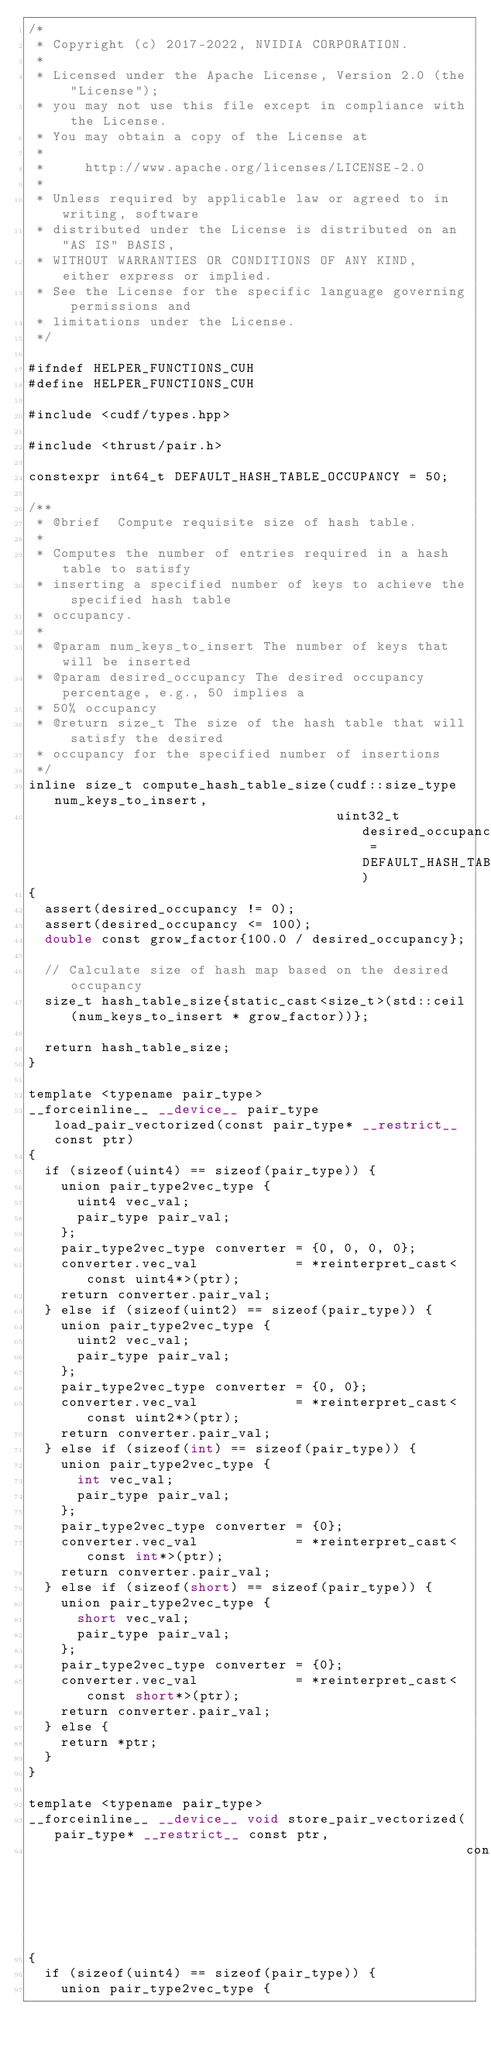<code> <loc_0><loc_0><loc_500><loc_500><_Cuda_>/*
 * Copyright (c) 2017-2022, NVIDIA CORPORATION.
 *
 * Licensed under the Apache License, Version 2.0 (the "License");
 * you may not use this file except in compliance with the License.
 * You may obtain a copy of the License at
 *
 *     http://www.apache.org/licenses/LICENSE-2.0
 *
 * Unless required by applicable law or agreed to in writing, software
 * distributed under the License is distributed on an "AS IS" BASIS,
 * WITHOUT WARRANTIES OR CONDITIONS OF ANY KIND, either express or implied.
 * See the License for the specific language governing permissions and
 * limitations under the License.
 */

#ifndef HELPER_FUNCTIONS_CUH
#define HELPER_FUNCTIONS_CUH

#include <cudf/types.hpp>

#include <thrust/pair.h>

constexpr int64_t DEFAULT_HASH_TABLE_OCCUPANCY = 50;

/**
 * @brief  Compute requisite size of hash table.
 *
 * Computes the number of entries required in a hash table to satisfy
 * inserting a specified number of keys to achieve the specified hash table
 * occupancy.
 *
 * @param num_keys_to_insert The number of keys that will be inserted
 * @param desired_occupancy The desired occupancy percentage, e.g., 50 implies a
 * 50% occupancy
 * @return size_t The size of the hash table that will satisfy the desired
 * occupancy for the specified number of insertions
 */
inline size_t compute_hash_table_size(cudf::size_type num_keys_to_insert,
                                      uint32_t desired_occupancy = DEFAULT_HASH_TABLE_OCCUPANCY)
{
  assert(desired_occupancy != 0);
  assert(desired_occupancy <= 100);
  double const grow_factor{100.0 / desired_occupancy};

  // Calculate size of hash map based on the desired occupancy
  size_t hash_table_size{static_cast<size_t>(std::ceil(num_keys_to_insert * grow_factor))};

  return hash_table_size;
}

template <typename pair_type>
__forceinline__ __device__ pair_type load_pair_vectorized(const pair_type* __restrict__ const ptr)
{
  if (sizeof(uint4) == sizeof(pair_type)) {
    union pair_type2vec_type {
      uint4 vec_val;
      pair_type pair_val;
    };
    pair_type2vec_type converter = {0, 0, 0, 0};
    converter.vec_val            = *reinterpret_cast<const uint4*>(ptr);
    return converter.pair_val;
  } else if (sizeof(uint2) == sizeof(pair_type)) {
    union pair_type2vec_type {
      uint2 vec_val;
      pair_type pair_val;
    };
    pair_type2vec_type converter = {0, 0};
    converter.vec_val            = *reinterpret_cast<const uint2*>(ptr);
    return converter.pair_val;
  } else if (sizeof(int) == sizeof(pair_type)) {
    union pair_type2vec_type {
      int vec_val;
      pair_type pair_val;
    };
    pair_type2vec_type converter = {0};
    converter.vec_val            = *reinterpret_cast<const int*>(ptr);
    return converter.pair_val;
  } else if (sizeof(short) == sizeof(pair_type)) {
    union pair_type2vec_type {
      short vec_val;
      pair_type pair_val;
    };
    pair_type2vec_type converter = {0};
    converter.vec_val            = *reinterpret_cast<const short*>(ptr);
    return converter.pair_val;
  } else {
    return *ptr;
  }
}

template <typename pair_type>
__forceinline__ __device__ void store_pair_vectorized(pair_type* __restrict__ const ptr,
                                                      const pair_type val)
{
  if (sizeof(uint4) == sizeof(pair_type)) {
    union pair_type2vec_type {</code> 